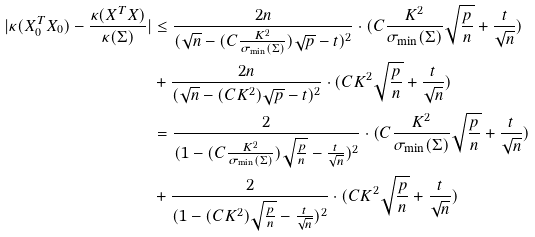<formula> <loc_0><loc_0><loc_500><loc_500>| \kappa ( X _ { 0 } ^ { T } X _ { 0 } ) - \frac { \kappa ( X ^ { T } X ) } { \kappa ( \Sigma ) } | & \leq \frac { 2 n } { ( \sqrt { n } - ( C \frac { K ^ { 2 } } { \sigma _ { \min } ( \Sigma ) } ) \sqrt { p } - t ) ^ { 2 } } \cdot ( C \frac { K ^ { 2 } } { \sigma _ { \min } ( \Sigma ) } \sqrt { \frac { p } { n } } + \frac { t } { \sqrt { n } } ) \\ & + \frac { 2 n } { ( \sqrt { n } - ( C K ^ { 2 } ) \sqrt { p } - t ) ^ { 2 } } \cdot ( C K ^ { 2 } \sqrt { \frac { p } { n } } + \frac { t } { \sqrt { n } } ) \\ & = \frac { 2 } { ( 1 - ( C \frac { K ^ { 2 } } { \sigma _ { \min } ( \Sigma ) } ) \sqrt { \frac { p } { n } } - \frac { t } { \sqrt { n } } ) ^ { 2 } } \cdot ( C \frac { K ^ { 2 } } { \sigma _ { \min } ( \Sigma ) } \sqrt { \frac { p } { n } } + \frac { t } { \sqrt { n } } ) \\ & + \frac { 2 } { ( 1 - ( C K ^ { 2 } ) \sqrt { \frac { p } { n } } - \frac { t } { \sqrt { n } } ) ^ { 2 } } \cdot ( C K ^ { 2 } \sqrt { \frac { p } { n } } + \frac { t } { \sqrt { n } } )</formula> 